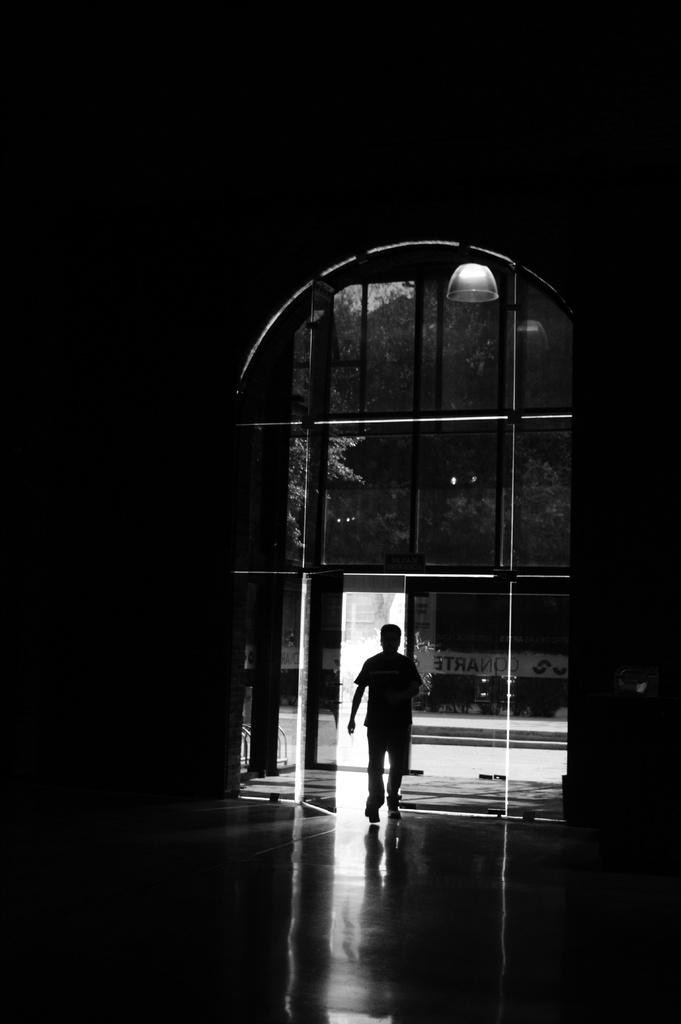What is the color scheme of the image? The image is black and white. Can you describe the main subject in the image? There is a person in the image. What can be seen beneath the person's feet? The ground is visible in the image. What object is present in the image that might be used for protection or visibility? There is glass in the image. What architectural feature is visible in the image? There is a door in the image. What type of natural environment is visible in the image? There are trees in the image. What source of illumination is present in the image? There is a light in the image. Are there any words or letters in the image? Yes, there is some text in the image. What type of shoe is the person wearing in the image? There is no shoe visible in the image, as it is a black and white image and shoes may not be distinguishable. How does the person feel about the situation depicted in the image? The image is in black and white and does not convey emotions or feelings, so it is not possible to determine how the person feels. 